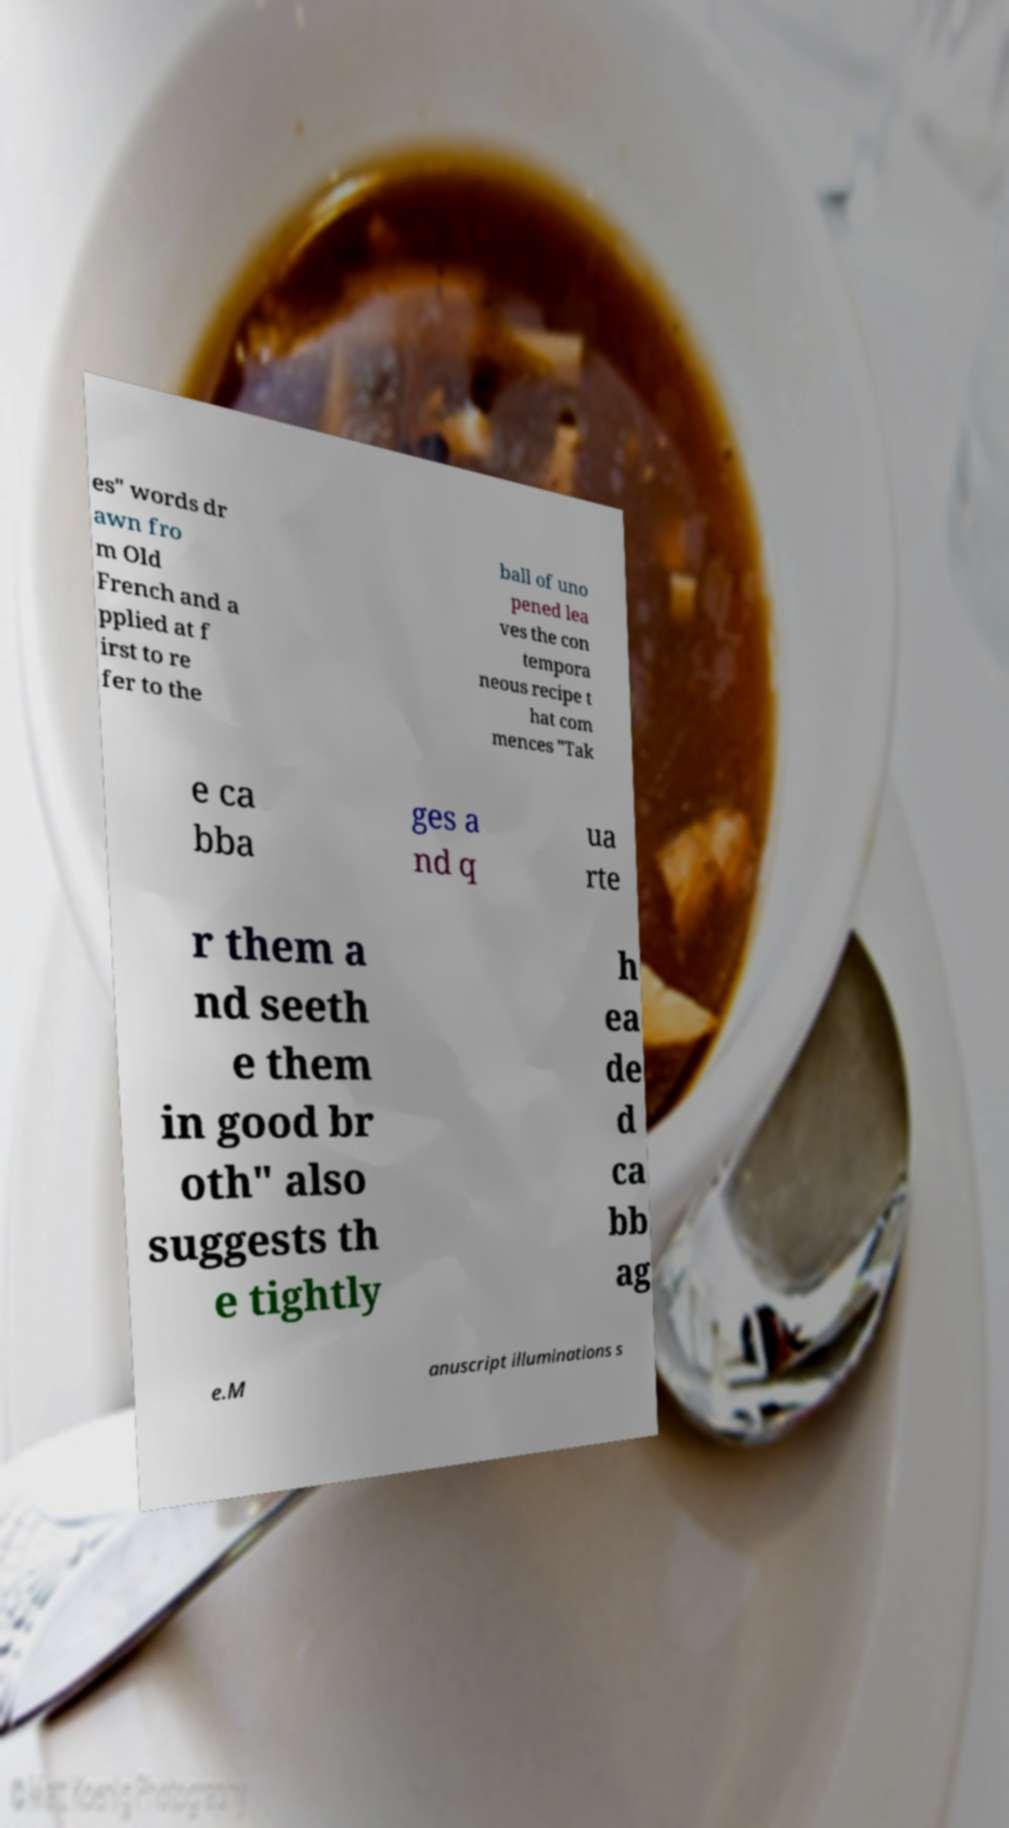Could you extract and type out the text from this image? es" words dr awn fro m Old French and a pplied at f irst to re fer to the ball of uno pened lea ves the con tempora neous recipe t hat com mences "Tak e ca bba ges a nd q ua rte r them a nd seeth e them in good br oth" also suggests th e tightly h ea de d ca bb ag e.M anuscript illuminations s 